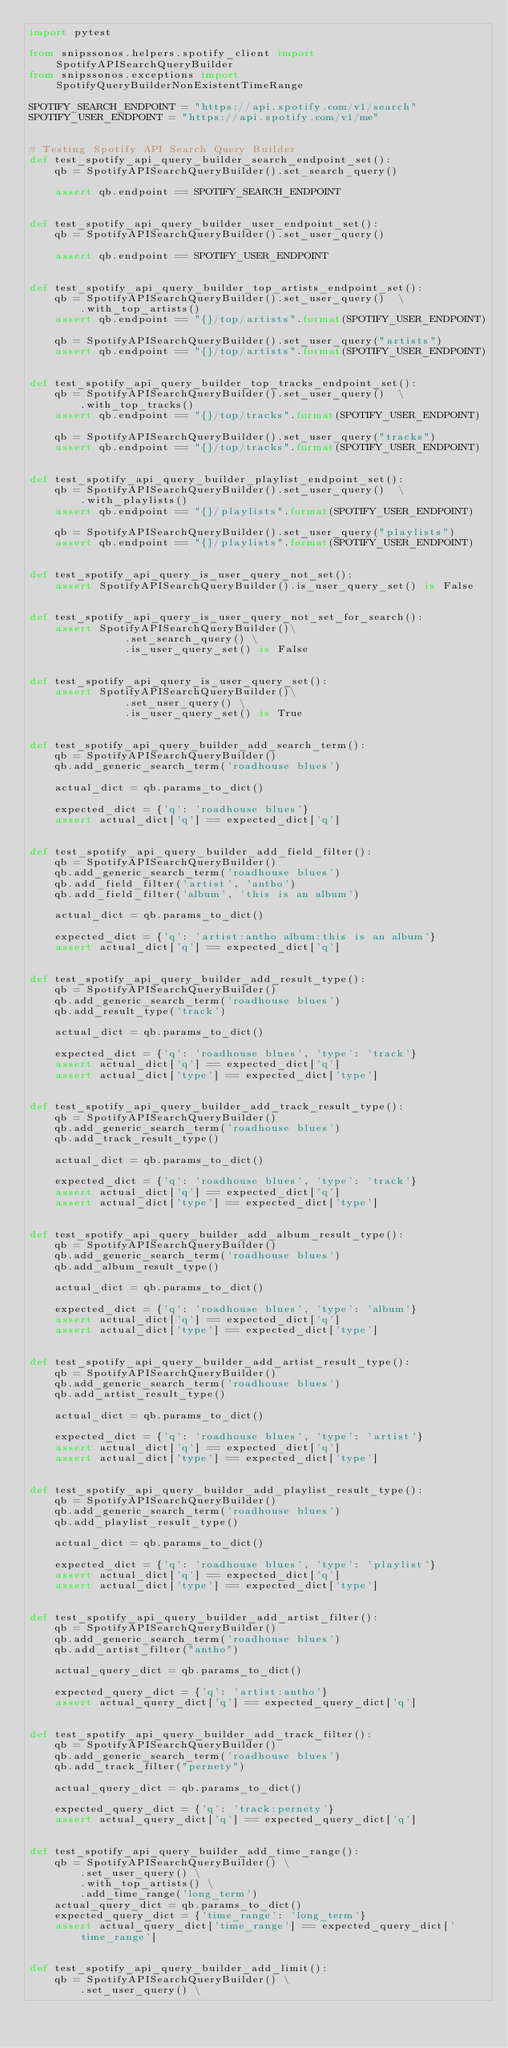Convert code to text. <code><loc_0><loc_0><loc_500><loc_500><_Python_>import pytest

from snipssonos.helpers.spotify_client import SpotifyAPISearchQueryBuilder
from snipssonos.exceptions import SpotifyQueryBuilderNonExistentTimeRange

SPOTIFY_SEARCH_ENDPOINT = "https://api.spotify.com/v1/search"
SPOTIFY_USER_ENDPOINT = "https://api.spotify.com/v1/me"


# Testing Spotify API Search Query Builder
def test_spotify_api_query_builder_search_endpoint_set():
    qb = SpotifyAPISearchQueryBuilder().set_search_query()

    assert qb.endpoint == SPOTIFY_SEARCH_ENDPOINT


def test_spotify_api_query_builder_user_endpoint_set():
    qb = SpotifyAPISearchQueryBuilder().set_user_query()

    assert qb.endpoint == SPOTIFY_USER_ENDPOINT


def test_spotify_api_query_builder_top_artists_endpoint_set():
    qb = SpotifyAPISearchQueryBuilder().set_user_query()  \
        .with_top_artists()
    assert qb.endpoint == "{}/top/artists".format(SPOTIFY_USER_ENDPOINT)

    qb = SpotifyAPISearchQueryBuilder().set_user_query("artists")
    assert qb.endpoint == "{}/top/artists".format(SPOTIFY_USER_ENDPOINT)


def test_spotify_api_query_builder_top_tracks_endpoint_set():
    qb = SpotifyAPISearchQueryBuilder().set_user_query()  \
        .with_top_tracks()
    assert qb.endpoint == "{}/top/tracks".format(SPOTIFY_USER_ENDPOINT)

    qb = SpotifyAPISearchQueryBuilder().set_user_query("tracks")
    assert qb.endpoint == "{}/top/tracks".format(SPOTIFY_USER_ENDPOINT)


def test_spotify_api_query_builder_playlist_endpoint_set():
    qb = SpotifyAPISearchQueryBuilder().set_user_query()  \
        .with_playlists()
    assert qb.endpoint == "{}/playlists".format(SPOTIFY_USER_ENDPOINT)

    qb = SpotifyAPISearchQueryBuilder().set_user_query("playlists")
    assert qb.endpoint == "{}/playlists".format(SPOTIFY_USER_ENDPOINT)


def test_spotify_api_query_is_user_query_not_set():
    assert SpotifyAPISearchQueryBuilder().is_user_query_set() is False


def test_spotify_api_query_is_user_query_not_set_for_search():
    assert SpotifyAPISearchQueryBuilder()\
               .set_search_query() \
               .is_user_query_set() is False


def test_spotify_api_query_is_user_query_set():
    assert SpotifyAPISearchQueryBuilder()\
               .set_user_query() \
               .is_user_query_set() is True


def test_spotify_api_query_builder_add_search_term():
    qb = SpotifyAPISearchQueryBuilder()
    qb.add_generic_search_term('roadhouse blues')

    actual_dict = qb.params_to_dict()

    expected_dict = {'q': 'roadhouse blues'}
    assert actual_dict['q'] == expected_dict['q']


def test_spotify_api_query_builder_add_field_filter():
    qb = SpotifyAPISearchQueryBuilder()
    qb.add_generic_search_term('roadhouse blues')
    qb.add_field_filter('artist', 'antho')
    qb.add_field_filter('album', 'this is an album')

    actual_dict = qb.params_to_dict()

    expected_dict = {'q': 'artist:antho album:this is an album'}
    assert actual_dict['q'] == expected_dict['q']


def test_spotify_api_query_builder_add_result_type():
    qb = SpotifyAPISearchQueryBuilder()
    qb.add_generic_search_term('roadhouse blues')
    qb.add_result_type('track')

    actual_dict = qb.params_to_dict()

    expected_dict = {'q': 'roadhouse blues', 'type': 'track'}
    assert actual_dict['q'] == expected_dict['q']
    assert actual_dict['type'] == expected_dict['type']


def test_spotify_api_query_builder_add_track_result_type():
    qb = SpotifyAPISearchQueryBuilder()
    qb.add_generic_search_term('roadhouse blues')
    qb.add_track_result_type()

    actual_dict = qb.params_to_dict()

    expected_dict = {'q': 'roadhouse blues', 'type': 'track'}
    assert actual_dict['q'] == expected_dict['q']
    assert actual_dict['type'] == expected_dict['type']


def test_spotify_api_query_builder_add_album_result_type():
    qb = SpotifyAPISearchQueryBuilder()
    qb.add_generic_search_term('roadhouse blues')
    qb.add_album_result_type()

    actual_dict = qb.params_to_dict()

    expected_dict = {'q': 'roadhouse blues', 'type': 'album'}
    assert actual_dict['q'] == expected_dict['q']
    assert actual_dict['type'] == expected_dict['type']


def test_spotify_api_query_builder_add_artist_result_type():
    qb = SpotifyAPISearchQueryBuilder()
    qb.add_generic_search_term('roadhouse blues')
    qb.add_artist_result_type()

    actual_dict = qb.params_to_dict()

    expected_dict = {'q': 'roadhouse blues', 'type': 'artist'}
    assert actual_dict['q'] == expected_dict['q']
    assert actual_dict['type'] == expected_dict['type']


def test_spotify_api_query_builder_add_playlist_result_type():
    qb = SpotifyAPISearchQueryBuilder()
    qb.add_generic_search_term('roadhouse blues')
    qb.add_playlist_result_type()

    actual_dict = qb.params_to_dict()

    expected_dict = {'q': 'roadhouse blues', 'type': 'playlist'}
    assert actual_dict['q'] == expected_dict['q']
    assert actual_dict['type'] == expected_dict['type']


def test_spotify_api_query_builder_add_artist_filter():
    qb = SpotifyAPISearchQueryBuilder()
    qb.add_generic_search_term('roadhouse blues')
    qb.add_artist_filter("antho")

    actual_query_dict = qb.params_to_dict()

    expected_query_dict = {'q': 'artist:antho'}
    assert actual_query_dict['q'] == expected_query_dict['q']


def test_spotify_api_query_builder_add_track_filter():
    qb = SpotifyAPISearchQueryBuilder()
    qb.add_generic_search_term('roadhouse blues')
    qb.add_track_filter("pernety")

    actual_query_dict = qb.params_to_dict()

    expected_query_dict = {'q': 'track:pernety'}
    assert actual_query_dict['q'] == expected_query_dict['q']


def test_spotify_api_query_builder_add_time_range():
    qb = SpotifyAPISearchQueryBuilder() \
        .set_user_query() \
        .with_top_artists() \
        .add_time_range('long_term')
    actual_query_dict = qb.params_to_dict()
    expected_query_dict = {'time_range': 'long_term'}
    assert actual_query_dict['time_range'] == expected_query_dict['time_range']


def test_spotify_api_query_builder_add_limit():
    qb = SpotifyAPISearchQueryBuilder() \
        .set_user_query() \</code> 